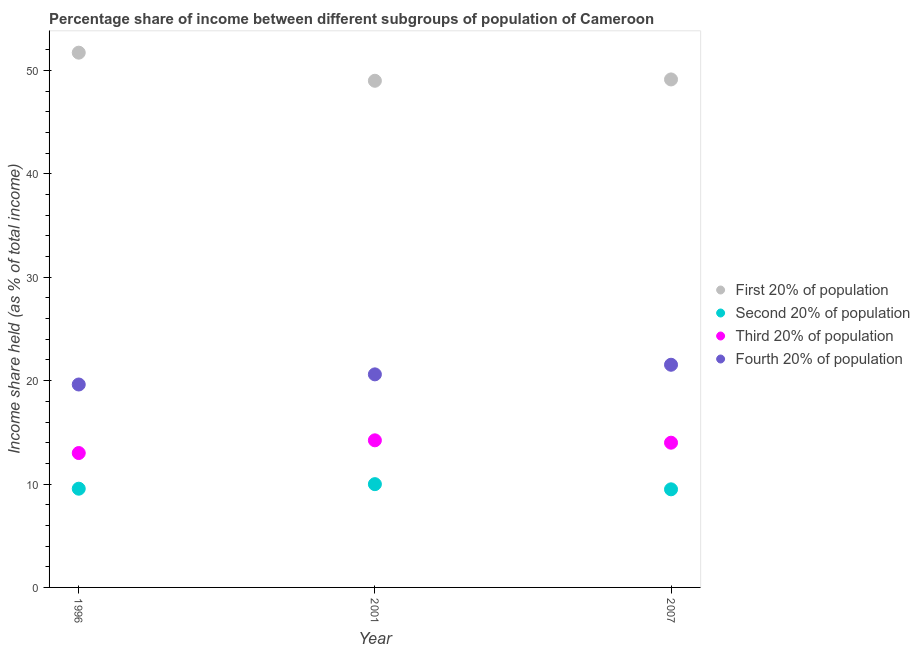Is the number of dotlines equal to the number of legend labels?
Your response must be concise. Yes. What is the share of the income held by fourth 20% of the population in 1996?
Keep it short and to the point. 19.63. Across all years, what is the maximum share of the income held by second 20% of the population?
Ensure brevity in your answer.  9.99. Across all years, what is the minimum share of the income held by first 20% of the population?
Your answer should be very brief. 49.01. In which year was the share of the income held by first 20% of the population minimum?
Keep it short and to the point. 2001. What is the total share of the income held by second 20% of the population in the graph?
Provide a short and direct response. 29.03. What is the difference between the share of the income held by fourth 20% of the population in 1996 and that in 2001?
Offer a terse response. -0.98. What is the difference between the share of the income held by first 20% of the population in 2007 and the share of the income held by third 20% of the population in 1996?
Ensure brevity in your answer.  36.14. What is the average share of the income held by first 20% of the population per year?
Ensure brevity in your answer.  49.96. In the year 2007, what is the difference between the share of the income held by fourth 20% of the population and share of the income held by third 20% of the population?
Offer a very short reply. 7.54. What is the ratio of the share of the income held by first 20% of the population in 1996 to that in 2001?
Provide a short and direct response. 1.06. Is the difference between the share of the income held by third 20% of the population in 2001 and 2007 greater than the difference between the share of the income held by first 20% of the population in 2001 and 2007?
Ensure brevity in your answer.  Yes. What is the difference between the highest and the second highest share of the income held by third 20% of the population?
Keep it short and to the point. 0.23. What is the difference between the highest and the lowest share of the income held by third 20% of the population?
Provide a succinct answer. 1.23. Is it the case that in every year, the sum of the share of the income held by third 20% of the population and share of the income held by second 20% of the population is greater than the sum of share of the income held by first 20% of the population and share of the income held by fourth 20% of the population?
Your response must be concise. No. Is it the case that in every year, the sum of the share of the income held by first 20% of the population and share of the income held by second 20% of the population is greater than the share of the income held by third 20% of the population?
Give a very brief answer. Yes. Does the share of the income held by fourth 20% of the population monotonically increase over the years?
Your answer should be compact. Yes. How many dotlines are there?
Offer a terse response. 4. How many years are there in the graph?
Give a very brief answer. 3. Does the graph contain grids?
Your answer should be compact. No. Where does the legend appear in the graph?
Give a very brief answer. Center right. How many legend labels are there?
Your response must be concise. 4. How are the legend labels stacked?
Make the answer very short. Vertical. What is the title of the graph?
Your response must be concise. Percentage share of income between different subgroups of population of Cameroon. What is the label or title of the X-axis?
Your answer should be very brief. Year. What is the label or title of the Y-axis?
Keep it short and to the point. Income share held (as % of total income). What is the Income share held (as % of total income) in First 20% of population in 1996?
Provide a short and direct response. 51.73. What is the Income share held (as % of total income) of Second 20% of population in 1996?
Your answer should be compact. 9.55. What is the Income share held (as % of total income) in Fourth 20% of population in 1996?
Provide a succinct answer. 19.63. What is the Income share held (as % of total income) of First 20% of population in 2001?
Ensure brevity in your answer.  49.01. What is the Income share held (as % of total income) in Second 20% of population in 2001?
Offer a terse response. 9.99. What is the Income share held (as % of total income) in Third 20% of population in 2001?
Offer a very short reply. 14.23. What is the Income share held (as % of total income) of Fourth 20% of population in 2001?
Your response must be concise. 20.61. What is the Income share held (as % of total income) in First 20% of population in 2007?
Your answer should be very brief. 49.14. What is the Income share held (as % of total income) of Second 20% of population in 2007?
Provide a short and direct response. 9.49. What is the Income share held (as % of total income) in Third 20% of population in 2007?
Your answer should be compact. 14. What is the Income share held (as % of total income) in Fourth 20% of population in 2007?
Offer a terse response. 21.54. Across all years, what is the maximum Income share held (as % of total income) in First 20% of population?
Provide a short and direct response. 51.73. Across all years, what is the maximum Income share held (as % of total income) of Second 20% of population?
Provide a succinct answer. 9.99. Across all years, what is the maximum Income share held (as % of total income) in Third 20% of population?
Your answer should be compact. 14.23. Across all years, what is the maximum Income share held (as % of total income) of Fourth 20% of population?
Offer a very short reply. 21.54. Across all years, what is the minimum Income share held (as % of total income) in First 20% of population?
Your answer should be compact. 49.01. Across all years, what is the minimum Income share held (as % of total income) of Second 20% of population?
Ensure brevity in your answer.  9.49. Across all years, what is the minimum Income share held (as % of total income) of Third 20% of population?
Your response must be concise. 13. Across all years, what is the minimum Income share held (as % of total income) in Fourth 20% of population?
Make the answer very short. 19.63. What is the total Income share held (as % of total income) in First 20% of population in the graph?
Keep it short and to the point. 149.88. What is the total Income share held (as % of total income) in Second 20% of population in the graph?
Offer a very short reply. 29.03. What is the total Income share held (as % of total income) of Third 20% of population in the graph?
Make the answer very short. 41.23. What is the total Income share held (as % of total income) of Fourth 20% of population in the graph?
Keep it short and to the point. 61.78. What is the difference between the Income share held (as % of total income) in First 20% of population in 1996 and that in 2001?
Give a very brief answer. 2.72. What is the difference between the Income share held (as % of total income) in Second 20% of population in 1996 and that in 2001?
Provide a succinct answer. -0.44. What is the difference between the Income share held (as % of total income) in Third 20% of population in 1996 and that in 2001?
Offer a very short reply. -1.23. What is the difference between the Income share held (as % of total income) in Fourth 20% of population in 1996 and that in 2001?
Your response must be concise. -0.98. What is the difference between the Income share held (as % of total income) in First 20% of population in 1996 and that in 2007?
Ensure brevity in your answer.  2.59. What is the difference between the Income share held (as % of total income) of Second 20% of population in 1996 and that in 2007?
Your answer should be compact. 0.06. What is the difference between the Income share held (as % of total income) in Fourth 20% of population in 1996 and that in 2007?
Offer a terse response. -1.91. What is the difference between the Income share held (as % of total income) of First 20% of population in 2001 and that in 2007?
Keep it short and to the point. -0.13. What is the difference between the Income share held (as % of total income) in Third 20% of population in 2001 and that in 2007?
Your answer should be very brief. 0.23. What is the difference between the Income share held (as % of total income) of Fourth 20% of population in 2001 and that in 2007?
Provide a short and direct response. -0.93. What is the difference between the Income share held (as % of total income) of First 20% of population in 1996 and the Income share held (as % of total income) of Second 20% of population in 2001?
Offer a terse response. 41.74. What is the difference between the Income share held (as % of total income) of First 20% of population in 1996 and the Income share held (as % of total income) of Third 20% of population in 2001?
Provide a succinct answer. 37.5. What is the difference between the Income share held (as % of total income) in First 20% of population in 1996 and the Income share held (as % of total income) in Fourth 20% of population in 2001?
Make the answer very short. 31.12. What is the difference between the Income share held (as % of total income) of Second 20% of population in 1996 and the Income share held (as % of total income) of Third 20% of population in 2001?
Offer a terse response. -4.68. What is the difference between the Income share held (as % of total income) in Second 20% of population in 1996 and the Income share held (as % of total income) in Fourth 20% of population in 2001?
Ensure brevity in your answer.  -11.06. What is the difference between the Income share held (as % of total income) in Third 20% of population in 1996 and the Income share held (as % of total income) in Fourth 20% of population in 2001?
Ensure brevity in your answer.  -7.61. What is the difference between the Income share held (as % of total income) in First 20% of population in 1996 and the Income share held (as % of total income) in Second 20% of population in 2007?
Ensure brevity in your answer.  42.24. What is the difference between the Income share held (as % of total income) of First 20% of population in 1996 and the Income share held (as % of total income) of Third 20% of population in 2007?
Provide a short and direct response. 37.73. What is the difference between the Income share held (as % of total income) in First 20% of population in 1996 and the Income share held (as % of total income) in Fourth 20% of population in 2007?
Provide a short and direct response. 30.19. What is the difference between the Income share held (as % of total income) of Second 20% of population in 1996 and the Income share held (as % of total income) of Third 20% of population in 2007?
Provide a short and direct response. -4.45. What is the difference between the Income share held (as % of total income) of Second 20% of population in 1996 and the Income share held (as % of total income) of Fourth 20% of population in 2007?
Your answer should be very brief. -11.99. What is the difference between the Income share held (as % of total income) in Third 20% of population in 1996 and the Income share held (as % of total income) in Fourth 20% of population in 2007?
Offer a very short reply. -8.54. What is the difference between the Income share held (as % of total income) of First 20% of population in 2001 and the Income share held (as % of total income) of Second 20% of population in 2007?
Your response must be concise. 39.52. What is the difference between the Income share held (as % of total income) of First 20% of population in 2001 and the Income share held (as % of total income) of Third 20% of population in 2007?
Give a very brief answer. 35.01. What is the difference between the Income share held (as % of total income) in First 20% of population in 2001 and the Income share held (as % of total income) in Fourth 20% of population in 2007?
Offer a terse response. 27.47. What is the difference between the Income share held (as % of total income) in Second 20% of population in 2001 and the Income share held (as % of total income) in Third 20% of population in 2007?
Provide a succinct answer. -4.01. What is the difference between the Income share held (as % of total income) in Second 20% of population in 2001 and the Income share held (as % of total income) in Fourth 20% of population in 2007?
Offer a very short reply. -11.55. What is the difference between the Income share held (as % of total income) of Third 20% of population in 2001 and the Income share held (as % of total income) of Fourth 20% of population in 2007?
Provide a succinct answer. -7.31. What is the average Income share held (as % of total income) of First 20% of population per year?
Provide a succinct answer. 49.96. What is the average Income share held (as % of total income) of Second 20% of population per year?
Your response must be concise. 9.68. What is the average Income share held (as % of total income) in Third 20% of population per year?
Your response must be concise. 13.74. What is the average Income share held (as % of total income) of Fourth 20% of population per year?
Offer a very short reply. 20.59. In the year 1996, what is the difference between the Income share held (as % of total income) in First 20% of population and Income share held (as % of total income) in Second 20% of population?
Your answer should be compact. 42.18. In the year 1996, what is the difference between the Income share held (as % of total income) in First 20% of population and Income share held (as % of total income) in Third 20% of population?
Give a very brief answer. 38.73. In the year 1996, what is the difference between the Income share held (as % of total income) of First 20% of population and Income share held (as % of total income) of Fourth 20% of population?
Your response must be concise. 32.1. In the year 1996, what is the difference between the Income share held (as % of total income) in Second 20% of population and Income share held (as % of total income) in Third 20% of population?
Provide a succinct answer. -3.45. In the year 1996, what is the difference between the Income share held (as % of total income) of Second 20% of population and Income share held (as % of total income) of Fourth 20% of population?
Provide a short and direct response. -10.08. In the year 1996, what is the difference between the Income share held (as % of total income) of Third 20% of population and Income share held (as % of total income) of Fourth 20% of population?
Give a very brief answer. -6.63. In the year 2001, what is the difference between the Income share held (as % of total income) in First 20% of population and Income share held (as % of total income) in Second 20% of population?
Offer a terse response. 39.02. In the year 2001, what is the difference between the Income share held (as % of total income) of First 20% of population and Income share held (as % of total income) of Third 20% of population?
Your answer should be compact. 34.78. In the year 2001, what is the difference between the Income share held (as % of total income) in First 20% of population and Income share held (as % of total income) in Fourth 20% of population?
Make the answer very short. 28.4. In the year 2001, what is the difference between the Income share held (as % of total income) in Second 20% of population and Income share held (as % of total income) in Third 20% of population?
Keep it short and to the point. -4.24. In the year 2001, what is the difference between the Income share held (as % of total income) in Second 20% of population and Income share held (as % of total income) in Fourth 20% of population?
Offer a terse response. -10.62. In the year 2001, what is the difference between the Income share held (as % of total income) in Third 20% of population and Income share held (as % of total income) in Fourth 20% of population?
Your answer should be compact. -6.38. In the year 2007, what is the difference between the Income share held (as % of total income) in First 20% of population and Income share held (as % of total income) in Second 20% of population?
Offer a very short reply. 39.65. In the year 2007, what is the difference between the Income share held (as % of total income) of First 20% of population and Income share held (as % of total income) of Third 20% of population?
Offer a very short reply. 35.14. In the year 2007, what is the difference between the Income share held (as % of total income) in First 20% of population and Income share held (as % of total income) in Fourth 20% of population?
Make the answer very short. 27.6. In the year 2007, what is the difference between the Income share held (as % of total income) in Second 20% of population and Income share held (as % of total income) in Third 20% of population?
Your response must be concise. -4.51. In the year 2007, what is the difference between the Income share held (as % of total income) in Second 20% of population and Income share held (as % of total income) in Fourth 20% of population?
Give a very brief answer. -12.05. In the year 2007, what is the difference between the Income share held (as % of total income) of Third 20% of population and Income share held (as % of total income) of Fourth 20% of population?
Give a very brief answer. -7.54. What is the ratio of the Income share held (as % of total income) in First 20% of population in 1996 to that in 2001?
Your answer should be compact. 1.06. What is the ratio of the Income share held (as % of total income) of Second 20% of population in 1996 to that in 2001?
Offer a very short reply. 0.96. What is the ratio of the Income share held (as % of total income) in Third 20% of population in 1996 to that in 2001?
Keep it short and to the point. 0.91. What is the ratio of the Income share held (as % of total income) of Fourth 20% of population in 1996 to that in 2001?
Offer a terse response. 0.95. What is the ratio of the Income share held (as % of total income) of First 20% of population in 1996 to that in 2007?
Keep it short and to the point. 1.05. What is the ratio of the Income share held (as % of total income) of Second 20% of population in 1996 to that in 2007?
Provide a short and direct response. 1.01. What is the ratio of the Income share held (as % of total income) of Fourth 20% of population in 1996 to that in 2007?
Offer a very short reply. 0.91. What is the ratio of the Income share held (as % of total income) in Second 20% of population in 2001 to that in 2007?
Give a very brief answer. 1.05. What is the ratio of the Income share held (as % of total income) in Third 20% of population in 2001 to that in 2007?
Provide a short and direct response. 1.02. What is the ratio of the Income share held (as % of total income) of Fourth 20% of population in 2001 to that in 2007?
Keep it short and to the point. 0.96. What is the difference between the highest and the second highest Income share held (as % of total income) of First 20% of population?
Keep it short and to the point. 2.59. What is the difference between the highest and the second highest Income share held (as % of total income) in Second 20% of population?
Keep it short and to the point. 0.44. What is the difference between the highest and the second highest Income share held (as % of total income) of Third 20% of population?
Give a very brief answer. 0.23. What is the difference between the highest and the second highest Income share held (as % of total income) in Fourth 20% of population?
Offer a very short reply. 0.93. What is the difference between the highest and the lowest Income share held (as % of total income) in First 20% of population?
Keep it short and to the point. 2.72. What is the difference between the highest and the lowest Income share held (as % of total income) in Third 20% of population?
Offer a terse response. 1.23. What is the difference between the highest and the lowest Income share held (as % of total income) in Fourth 20% of population?
Make the answer very short. 1.91. 